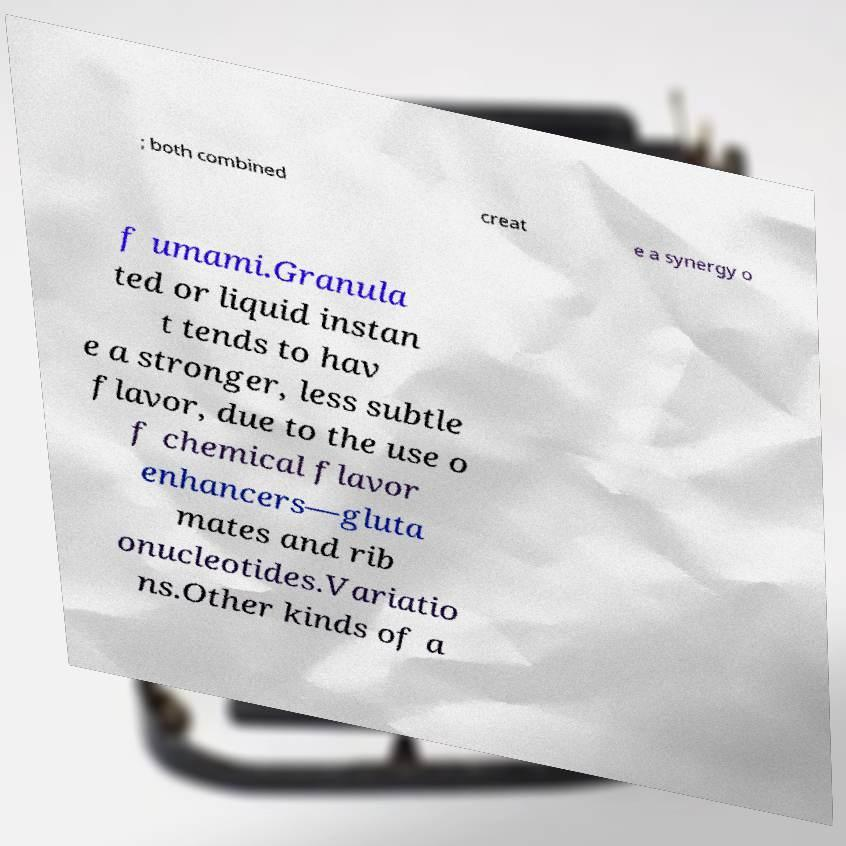Can you read and provide the text displayed in the image?This photo seems to have some interesting text. Can you extract and type it out for me? ; both combined creat e a synergy o f umami.Granula ted or liquid instan t tends to hav e a stronger, less subtle flavor, due to the use o f chemical flavor enhancers—gluta mates and rib onucleotides.Variatio ns.Other kinds of a 